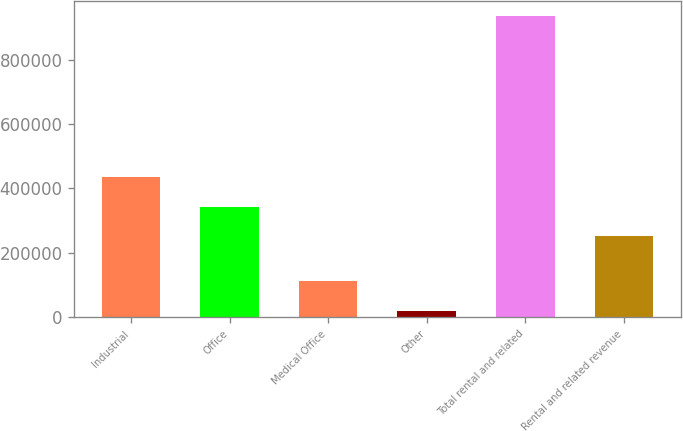Convert chart to OTSL. <chart><loc_0><loc_0><loc_500><loc_500><bar_chart><fcel>Industrial<fcel>Office<fcel>Medical Office<fcel>Other<fcel>Total rental and related<fcel>Rental and related revenue<nl><fcel>434382<fcel>342594<fcel>110962<fcel>19175<fcel>937049<fcel>250807<nl></chart> 